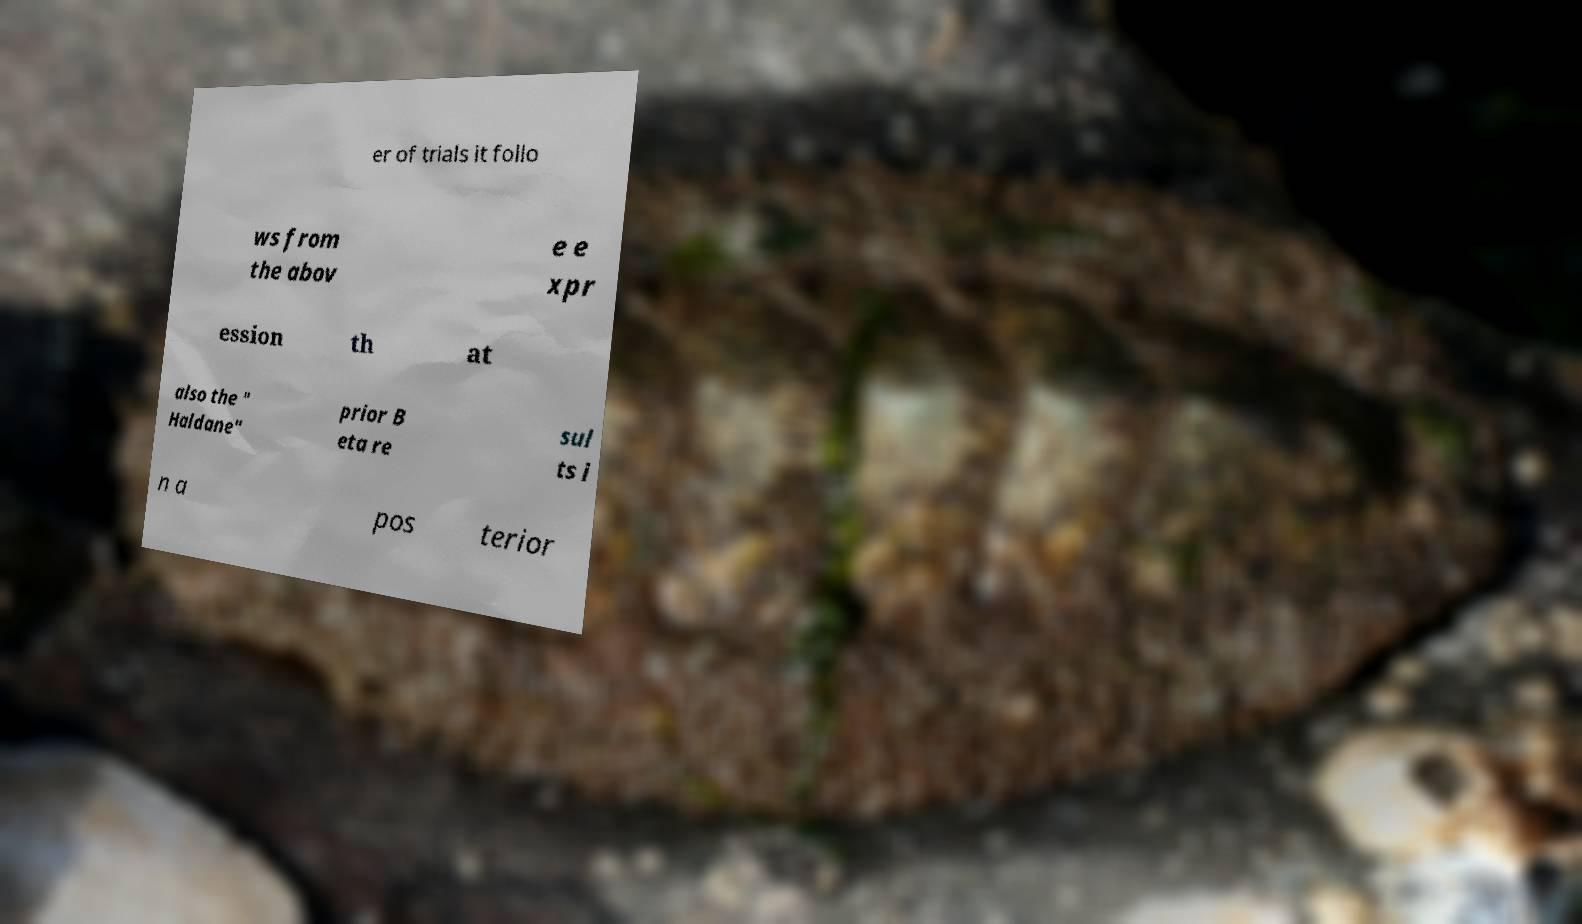Could you extract and type out the text from this image? er of trials it follo ws from the abov e e xpr ession th at also the " Haldane" prior B eta re sul ts i n a pos terior 